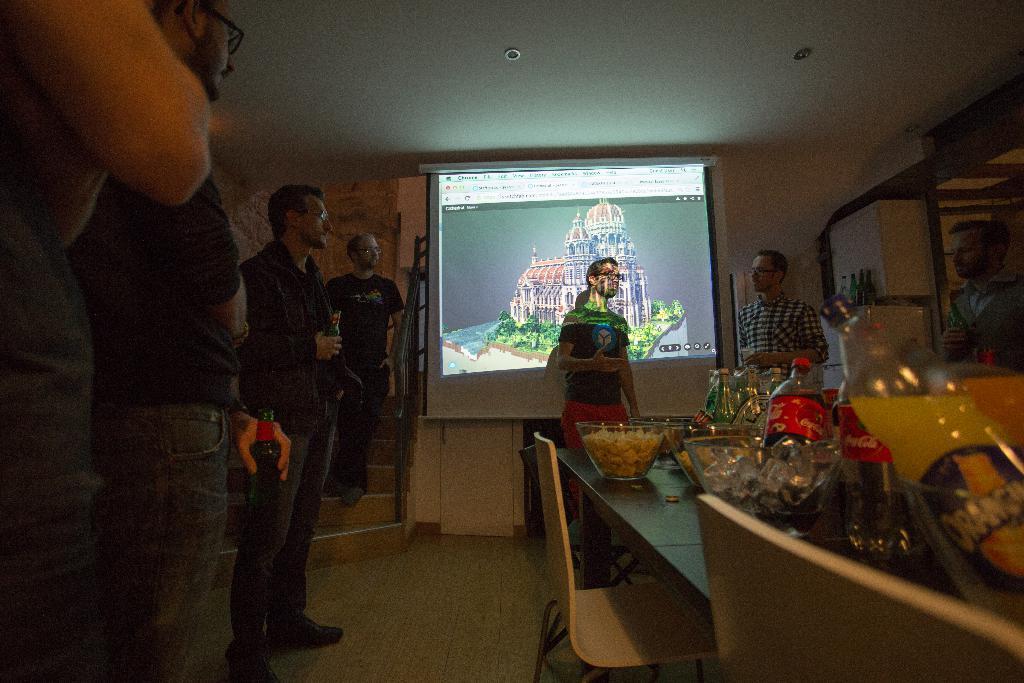Can you describe this image briefly? There are few people standing. This is the table with bowls and bottles placed on it. These are the chairs. This is the screen with display on it. I think these are the ceiling lights attached to the rooftop. These are the stairs with a staircase holder. 